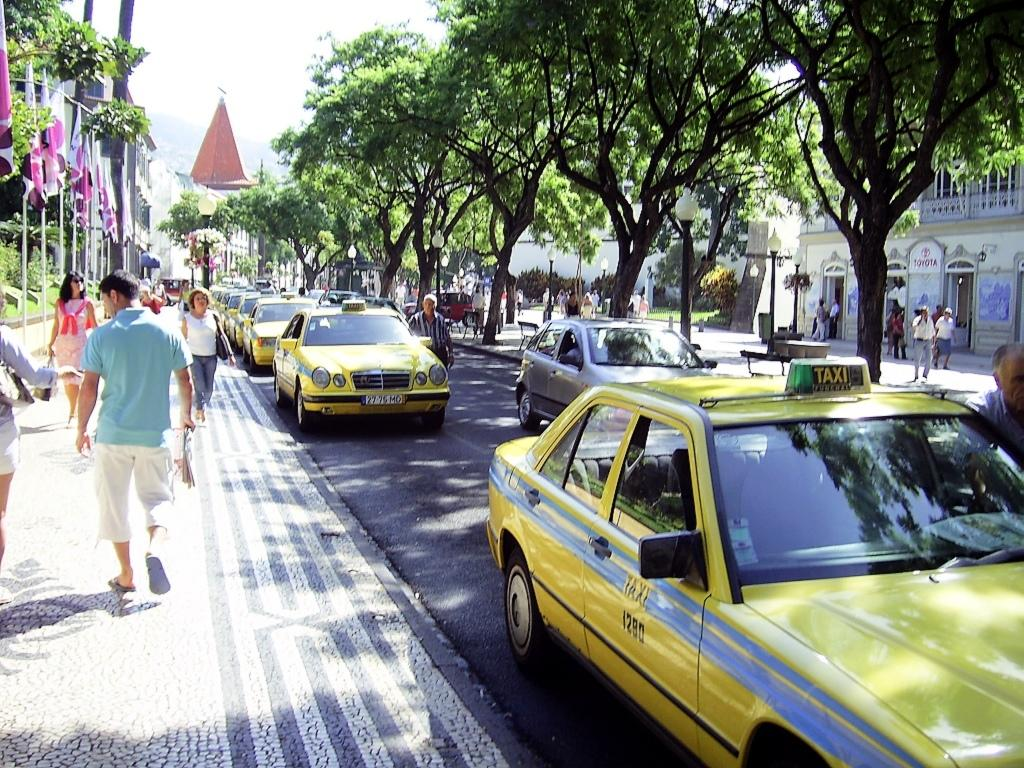<image>
Write a terse but informative summary of the picture. Yellow taxis line up on a sunny day in the street 